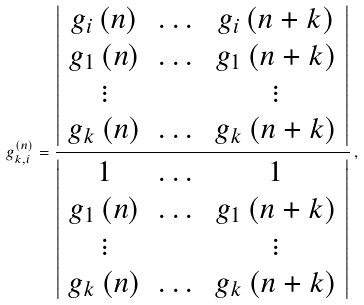<formula> <loc_0><loc_0><loc_500><loc_500>g _ { k , i } ^ { \left ( n \right ) } = \frac { \left | \begin{array} { c c c } g _ { i } \left ( n \right ) & \dots & g _ { i } \left ( n + k \right ) \\ g _ { 1 } \left ( n \right ) & \dots & g _ { 1 } \left ( n + k \right ) \\ \vdots & & \vdots \\ g _ { k } \left ( n \right ) & \dots & g _ { k } \left ( n + k \right ) \end{array} \right | } { \left | \begin{array} { c c c } 1 & \dots & 1 \\ g _ { 1 } \left ( n \right ) & \dots & g _ { 1 } \left ( n + k \right ) \\ \vdots & & \vdots \\ g _ { k } \left ( n \right ) & \dots & g _ { k } \left ( n + k \right ) \end{array} \right | } \, ,</formula> 